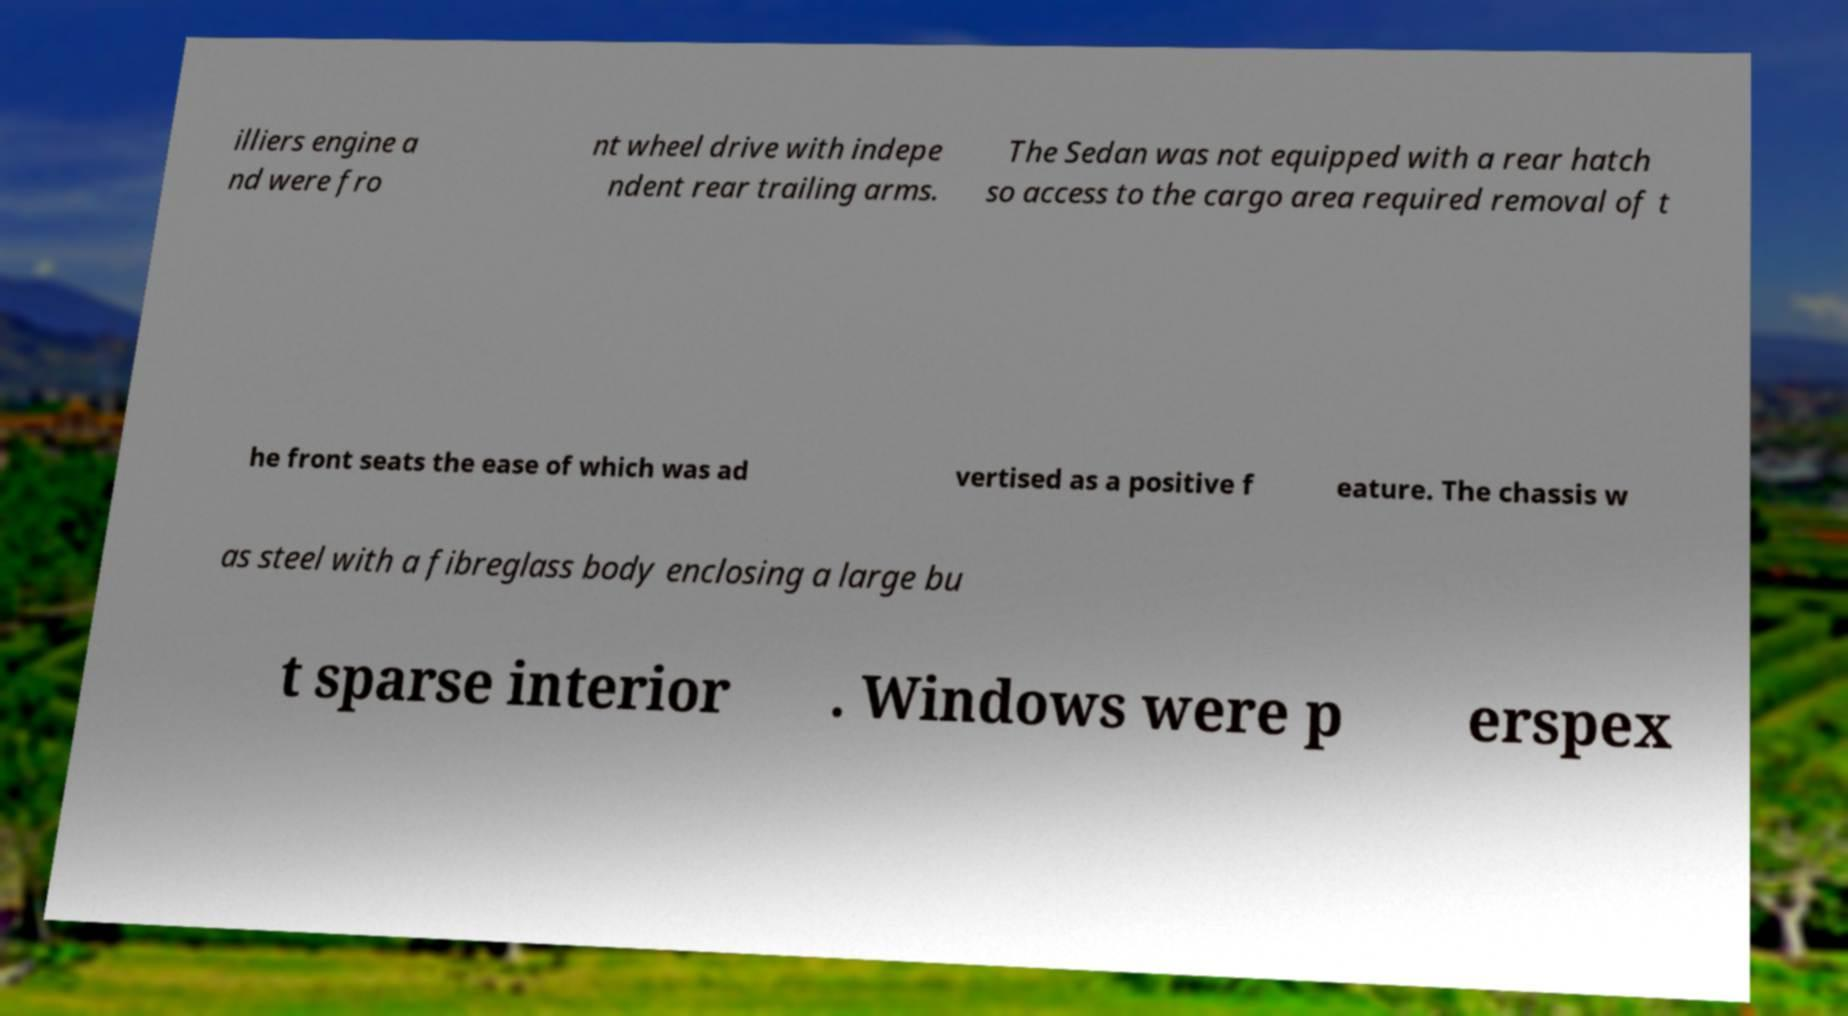Could you assist in decoding the text presented in this image and type it out clearly? illiers engine a nd were fro nt wheel drive with indepe ndent rear trailing arms. The Sedan was not equipped with a rear hatch so access to the cargo area required removal of t he front seats the ease of which was ad vertised as a positive f eature. The chassis w as steel with a fibreglass body enclosing a large bu t sparse interior . Windows were p erspex 